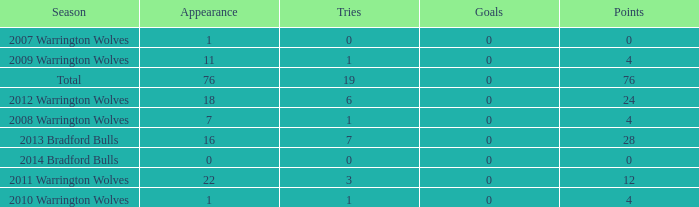What is the sum of appearance when goals is more than 0? None. 